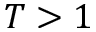<formula> <loc_0><loc_0><loc_500><loc_500>T > 1</formula> 